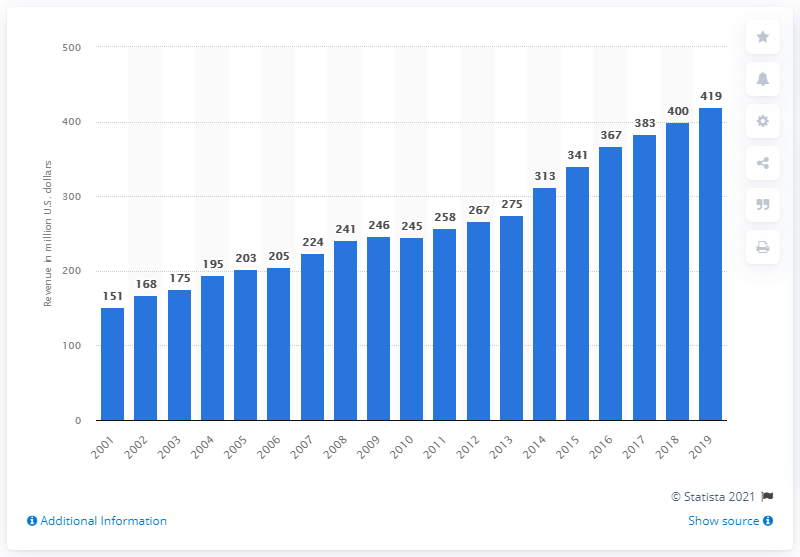What does the decline in revenue from 2016 to 2017 indicate? The drop in revenue from $383 million in 2016 to $367 million in 2017 might suggest a temporary challenge such as less successful seasons, or changes in ticket pricing or merchandising strategies. It often reflects fluctuations in success on the field that can directly influence fans' engagement and spending. 